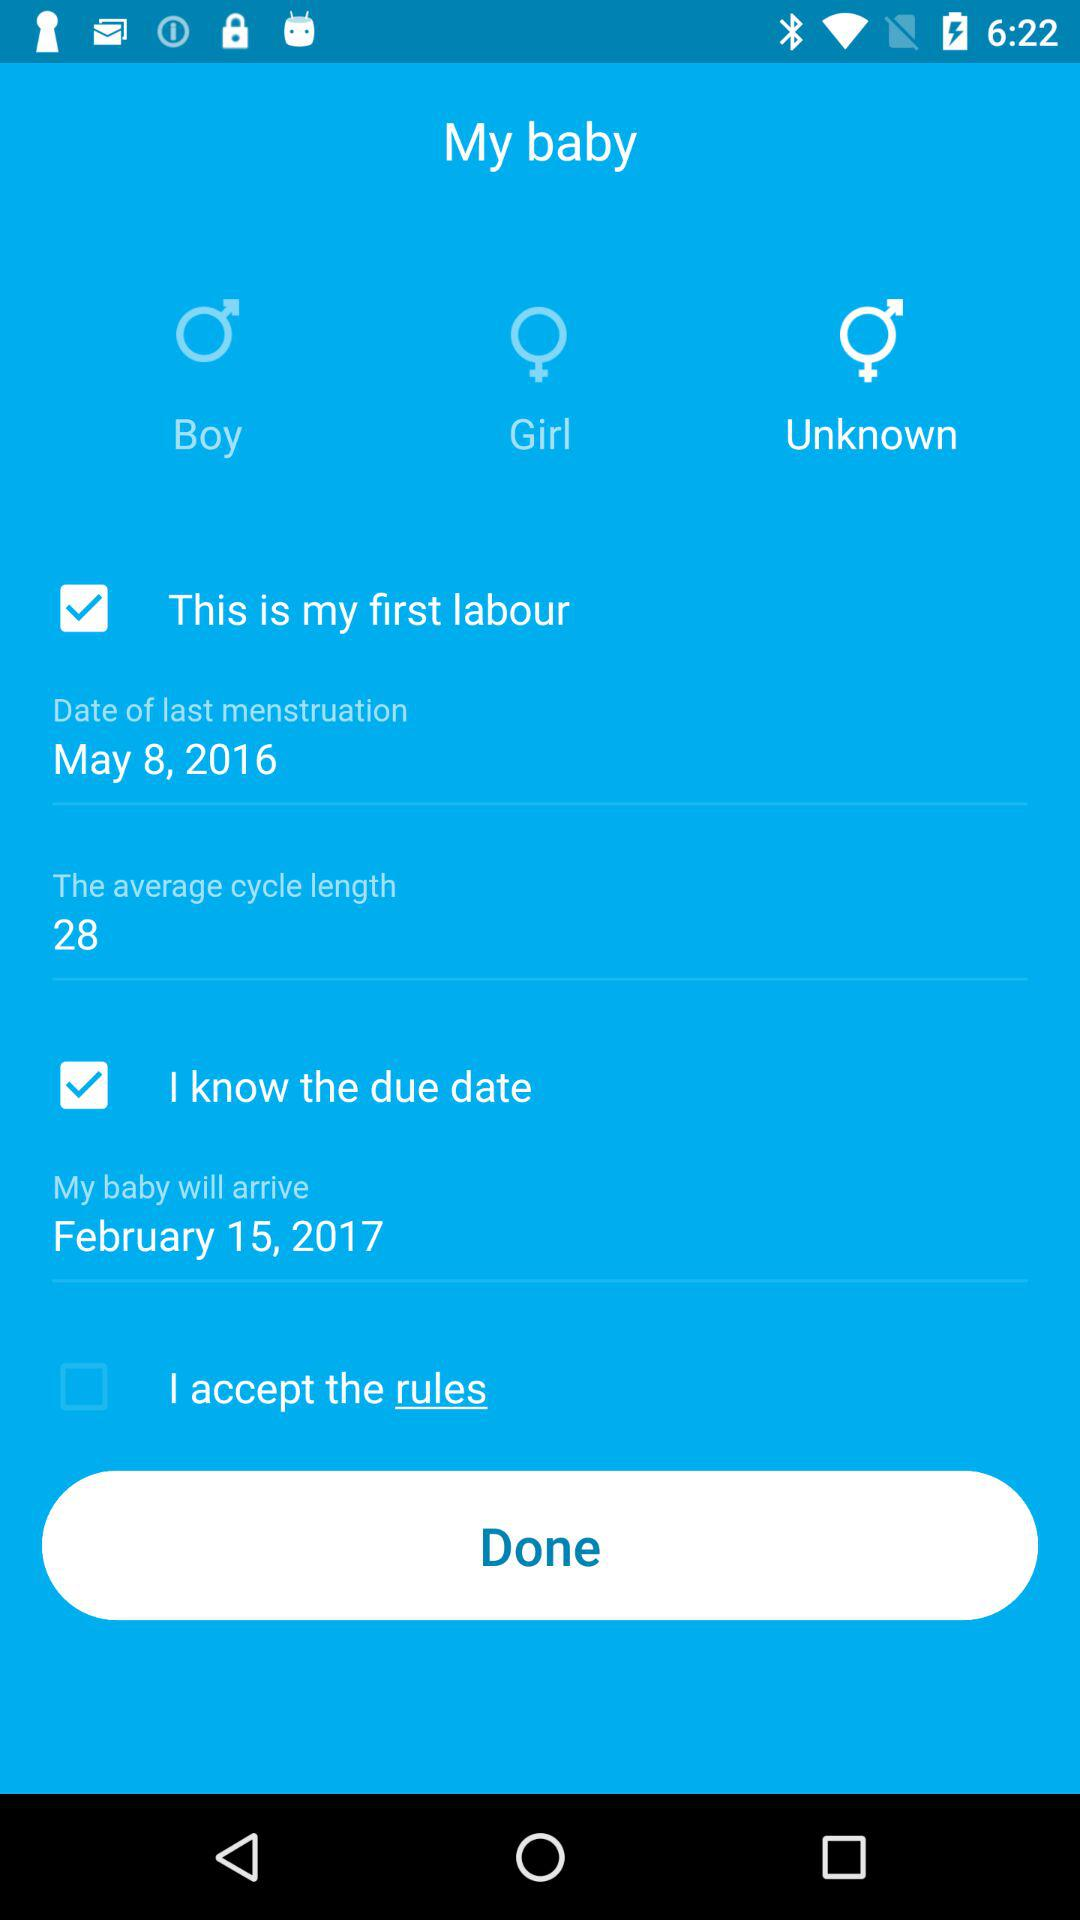What is the gender selected? The selected gender is "Unknown". 